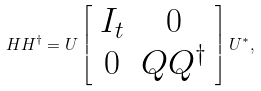<formula> <loc_0><loc_0><loc_500><loc_500>H H ^ { \dag } = U \left [ \begin{array} { c c } I _ { t } & 0 \\ 0 & Q Q ^ { \dag } \\ \end{array} \right ] U ^ { * } ,</formula> 